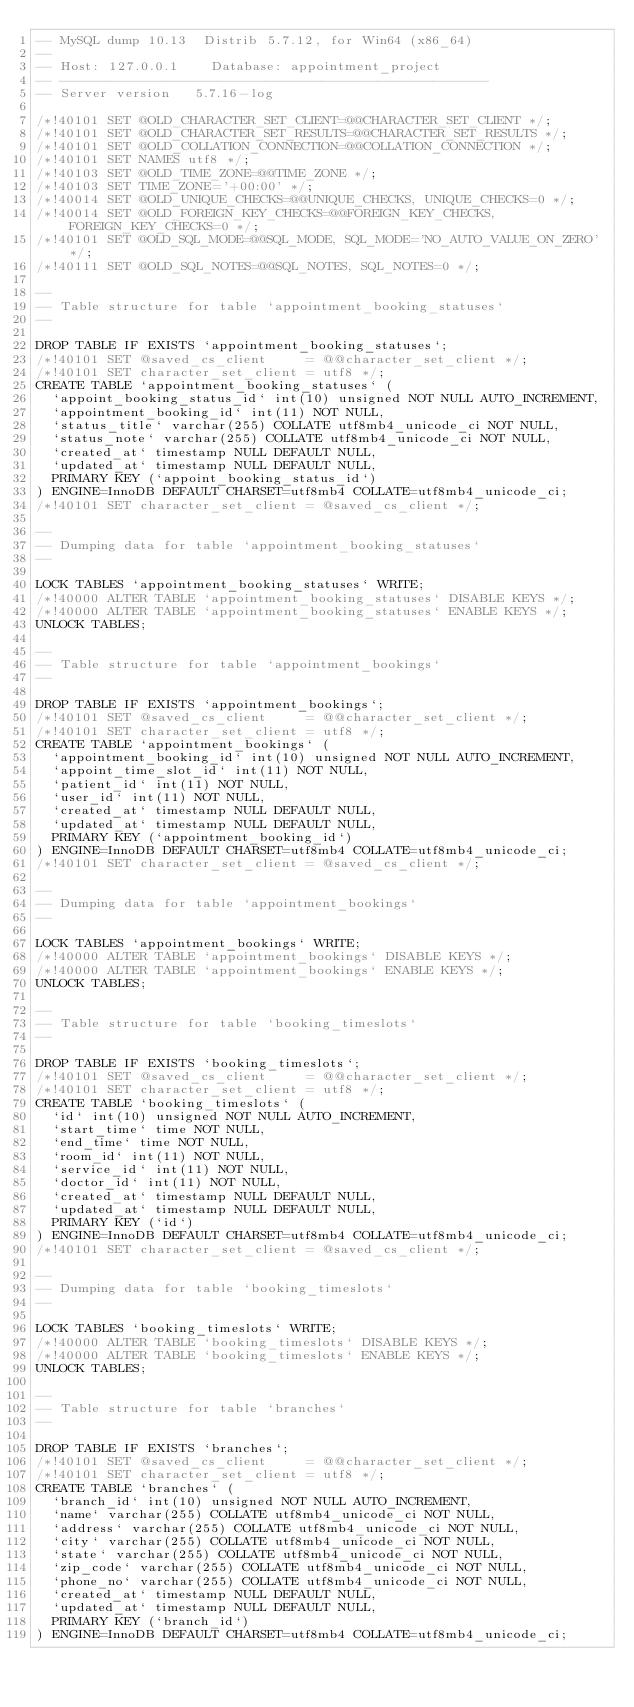Convert code to text. <code><loc_0><loc_0><loc_500><loc_500><_SQL_>-- MySQL dump 10.13  Distrib 5.7.12, for Win64 (x86_64)
--
-- Host: 127.0.0.1    Database: appointment_project
-- ------------------------------------------------------
-- Server version	5.7.16-log

/*!40101 SET @OLD_CHARACTER_SET_CLIENT=@@CHARACTER_SET_CLIENT */;
/*!40101 SET @OLD_CHARACTER_SET_RESULTS=@@CHARACTER_SET_RESULTS */;
/*!40101 SET @OLD_COLLATION_CONNECTION=@@COLLATION_CONNECTION */;
/*!40101 SET NAMES utf8 */;
/*!40103 SET @OLD_TIME_ZONE=@@TIME_ZONE */;
/*!40103 SET TIME_ZONE='+00:00' */;
/*!40014 SET @OLD_UNIQUE_CHECKS=@@UNIQUE_CHECKS, UNIQUE_CHECKS=0 */;
/*!40014 SET @OLD_FOREIGN_KEY_CHECKS=@@FOREIGN_KEY_CHECKS, FOREIGN_KEY_CHECKS=0 */;
/*!40101 SET @OLD_SQL_MODE=@@SQL_MODE, SQL_MODE='NO_AUTO_VALUE_ON_ZERO' */;
/*!40111 SET @OLD_SQL_NOTES=@@SQL_NOTES, SQL_NOTES=0 */;

--
-- Table structure for table `appointment_booking_statuses`
--

DROP TABLE IF EXISTS `appointment_booking_statuses`;
/*!40101 SET @saved_cs_client     = @@character_set_client */;
/*!40101 SET character_set_client = utf8 */;
CREATE TABLE `appointment_booking_statuses` (
  `appoint_booking_status_id` int(10) unsigned NOT NULL AUTO_INCREMENT,
  `appointment_booking_id` int(11) NOT NULL,
  `status_title` varchar(255) COLLATE utf8mb4_unicode_ci NOT NULL,
  `status_note` varchar(255) COLLATE utf8mb4_unicode_ci NOT NULL,
  `created_at` timestamp NULL DEFAULT NULL,
  `updated_at` timestamp NULL DEFAULT NULL,
  PRIMARY KEY (`appoint_booking_status_id`)
) ENGINE=InnoDB DEFAULT CHARSET=utf8mb4 COLLATE=utf8mb4_unicode_ci;
/*!40101 SET character_set_client = @saved_cs_client */;

--
-- Dumping data for table `appointment_booking_statuses`
--

LOCK TABLES `appointment_booking_statuses` WRITE;
/*!40000 ALTER TABLE `appointment_booking_statuses` DISABLE KEYS */;
/*!40000 ALTER TABLE `appointment_booking_statuses` ENABLE KEYS */;
UNLOCK TABLES;

--
-- Table structure for table `appointment_bookings`
--

DROP TABLE IF EXISTS `appointment_bookings`;
/*!40101 SET @saved_cs_client     = @@character_set_client */;
/*!40101 SET character_set_client = utf8 */;
CREATE TABLE `appointment_bookings` (
  `appointment_booking_id` int(10) unsigned NOT NULL AUTO_INCREMENT,
  `appoint_time_slot_id` int(11) NOT NULL,
  `patient_id` int(11) NOT NULL,
  `user_id` int(11) NOT NULL,
  `created_at` timestamp NULL DEFAULT NULL,
  `updated_at` timestamp NULL DEFAULT NULL,
  PRIMARY KEY (`appointment_booking_id`)
) ENGINE=InnoDB DEFAULT CHARSET=utf8mb4 COLLATE=utf8mb4_unicode_ci;
/*!40101 SET character_set_client = @saved_cs_client */;

--
-- Dumping data for table `appointment_bookings`
--

LOCK TABLES `appointment_bookings` WRITE;
/*!40000 ALTER TABLE `appointment_bookings` DISABLE KEYS */;
/*!40000 ALTER TABLE `appointment_bookings` ENABLE KEYS */;
UNLOCK TABLES;

--
-- Table structure for table `booking_timeslots`
--

DROP TABLE IF EXISTS `booking_timeslots`;
/*!40101 SET @saved_cs_client     = @@character_set_client */;
/*!40101 SET character_set_client = utf8 */;
CREATE TABLE `booking_timeslots` (
  `id` int(10) unsigned NOT NULL AUTO_INCREMENT,
  `start_time` time NOT NULL,
  `end_time` time NOT NULL,
  `room_id` int(11) NOT NULL,
  `service_id` int(11) NOT NULL,
  `doctor_id` int(11) NOT NULL,
  `created_at` timestamp NULL DEFAULT NULL,
  `updated_at` timestamp NULL DEFAULT NULL,
  PRIMARY KEY (`id`)
) ENGINE=InnoDB DEFAULT CHARSET=utf8mb4 COLLATE=utf8mb4_unicode_ci;
/*!40101 SET character_set_client = @saved_cs_client */;

--
-- Dumping data for table `booking_timeslots`
--

LOCK TABLES `booking_timeslots` WRITE;
/*!40000 ALTER TABLE `booking_timeslots` DISABLE KEYS */;
/*!40000 ALTER TABLE `booking_timeslots` ENABLE KEYS */;
UNLOCK TABLES;

--
-- Table structure for table `branches`
--

DROP TABLE IF EXISTS `branches`;
/*!40101 SET @saved_cs_client     = @@character_set_client */;
/*!40101 SET character_set_client = utf8 */;
CREATE TABLE `branches` (
  `branch_id` int(10) unsigned NOT NULL AUTO_INCREMENT,
  `name` varchar(255) COLLATE utf8mb4_unicode_ci NOT NULL,
  `address` varchar(255) COLLATE utf8mb4_unicode_ci NOT NULL,
  `city` varchar(255) COLLATE utf8mb4_unicode_ci NOT NULL,
  `state` varchar(255) COLLATE utf8mb4_unicode_ci NOT NULL,
  `zip_code` varchar(255) COLLATE utf8mb4_unicode_ci NOT NULL,
  `phone_no` varchar(255) COLLATE utf8mb4_unicode_ci NOT NULL,
  `created_at` timestamp NULL DEFAULT NULL,
  `updated_at` timestamp NULL DEFAULT NULL,
  PRIMARY KEY (`branch_id`)
) ENGINE=InnoDB DEFAULT CHARSET=utf8mb4 COLLATE=utf8mb4_unicode_ci;</code> 